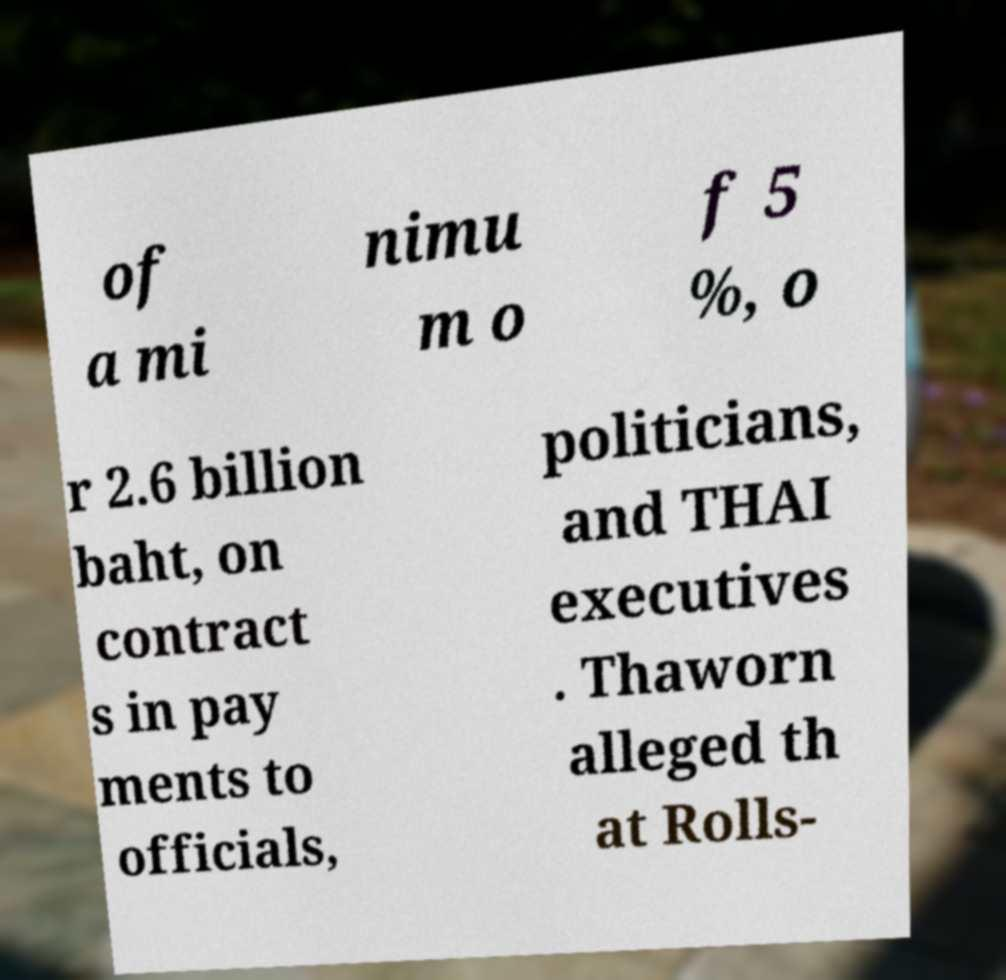For documentation purposes, I need the text within this image transcribed. Could you provide that? of a mi nimu m o f 5 %, o r 2.6 billion baht, on contract s in pay ments to officials, politicians, and THAI executives . Thaworn alleged th at Rolls- 